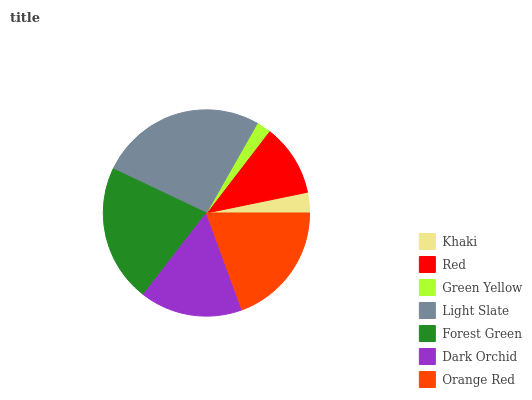Is Green Yellow the minimum?
Answer yes or no. Yes. Is Light Slate the maximum?
Answer yes or no. Yes. Is Red the minimum?
Answer yes or no. No. Is Red the maximum?
Answer yes or no. No. Is Red greater than Khaki?
Answer yes or no. Yes. Is Khaki less than Red?
Answer yes or no. Yes. Is Khaki greater than Red?
Answer yes or no. No. Is Red less than Khaki?
Answer yes or no. No. Is Dark Orchid the high median?
Answer yes or no. Yes. Is Dark Orchid the low median?
Answer yes or no. Yes. Is Green Yellow the high median?
Answer yes or no. No. Is Khaki the low median?
Answer yes or no. No. 